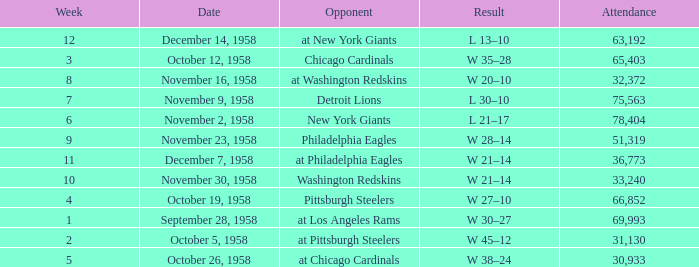What day had over 51,319 attending week 4? October 19, 1958. 